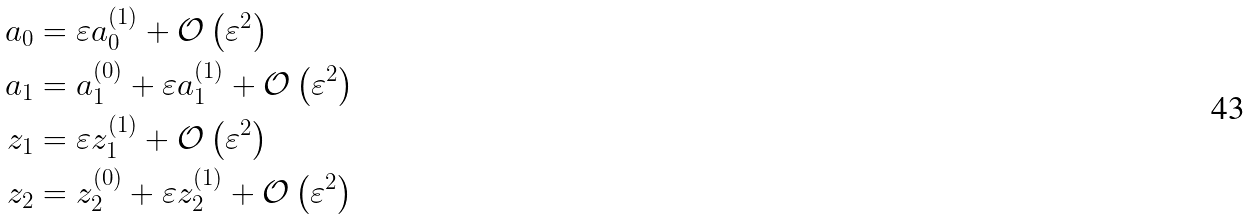Convert formula to latex. <formula><loc_0><loc_0><loc_500><loc_500>a _ { 0 } & = \varepsilon a _ { 0 } ^ { ( 1 ) } + \mathcal { O } \left ( \varepsilon ^ { 2 } \right ) \\ a _ { 1 } & = a _ { 1 } ^ { ( 0 ) } + \varepsilon a _ { 1 } ^ { ( 1 ) } + \mathcal { O } \left ( \varepsilon ^ { 2 } \right ) \\ z _ { 1 } & = \varepsilon z _ { 1 } ^ { ( 1 ) } + \mathcal { O } \left ( \varepsilon ^ { 2 } \right ) \\ z _ { 2 } & = z _ { 2 } ^ { ( 0 ) } + \varepsilon z _ { 2 } ^ { ( 1 ) } + \mathcal { O } \left ( \varepsilon ^ { 2 } \right )</formula> 